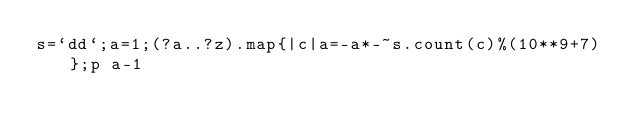<code> <loc_0><loc_0><loc_500><loc_500><_Ruby_>s=`dd`;a=1;(?a..?z).map{|c|a=-a*-~s.count(c)%(10**9+7)};p a-1</code> 